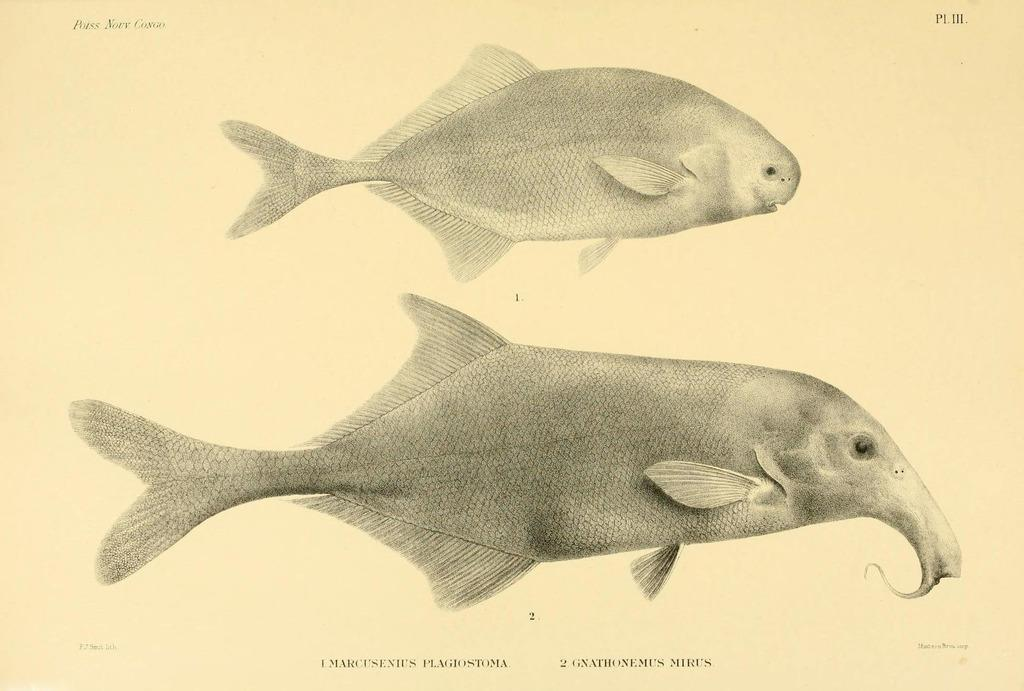What is depicted on the paper in the image? The paper contains an art of two fishes. What else can be found on the paper besides the art? There is text on the paper. What type of wool is used to create the design on the paper? There is no wool mentioned or depicted in the image. The art on the paper is likely created using ink or another type of drawing material. 